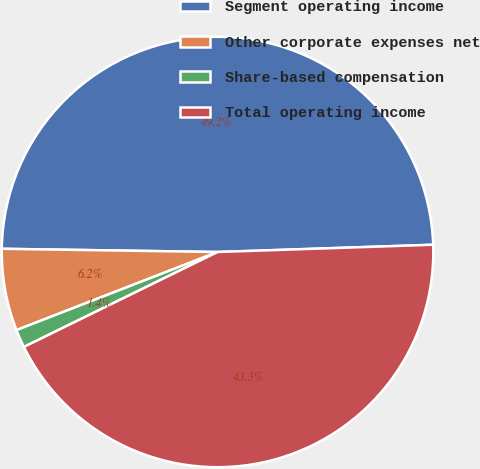Convert chart. <chart><loc_0><loc_0><loc_500><loc_500><pie_chart><fcel>Segment operating income<fcel>Other corporate expenses net<fcel>Share-based compensation<fcel>Total operating income<nl><fcel>49.22%<fcel>6.15%<fcel>1.36%<fcel>43.26%<nl></chart> 